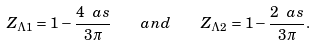Convert formula to latex. <formula><loc_0><loc_0><loc_500><loc_500>Z _ { \Lambda 1 } = 1 - \frac { 4 \ a s } { 3 \pi } \quad a n d \quad Z _ { \Lambda 2 } = 1 - \frac { 2 \ a s } { 3 \pi } .</formula> 